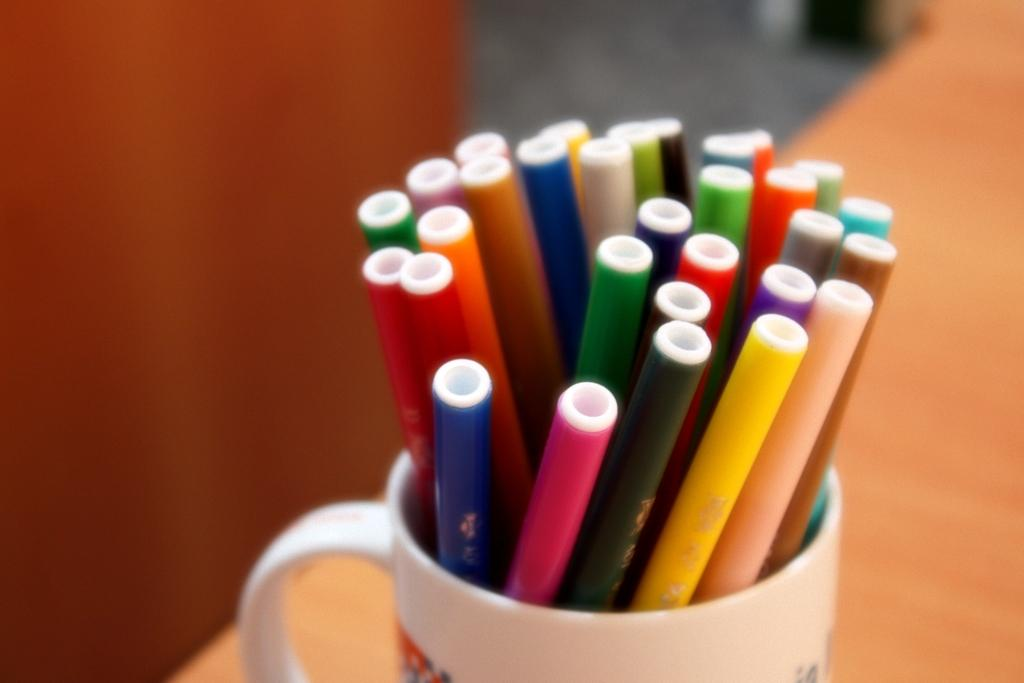What type of writing or drawing instruments are in the image? There are sketch pens in the image. How are the sketch pens arranged or stored in the image? The sketch pens are kept in a cup. What type of love is expressed between the parent and the boy in the image? There is no parent or boy present in the image, and therefore no such interaction can be observed. 